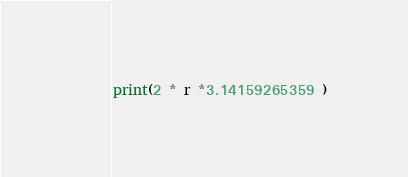Convert code to text. <code><loc_0><loc_0><loc_500><loc_500><_Python_>print(2 * r *3.14159265359 )</code> 